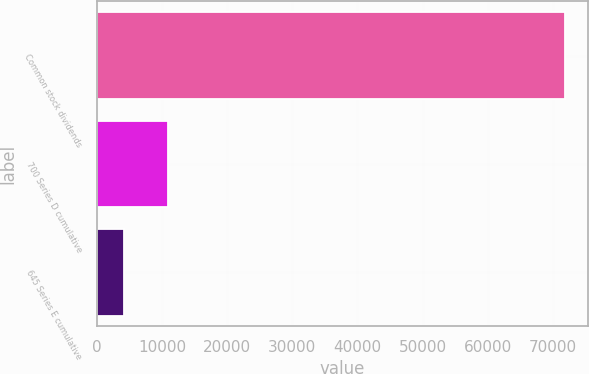<chart> <loc_0><loc_0><loc_500><loc_500><bar_chart><fcel>Common stock dividends<fcel>700 Series D cumulative<fcel>645 Series E cumulative<nl><fcel>71784<fcel>10951.2<fcel>4192<nl></chart> 